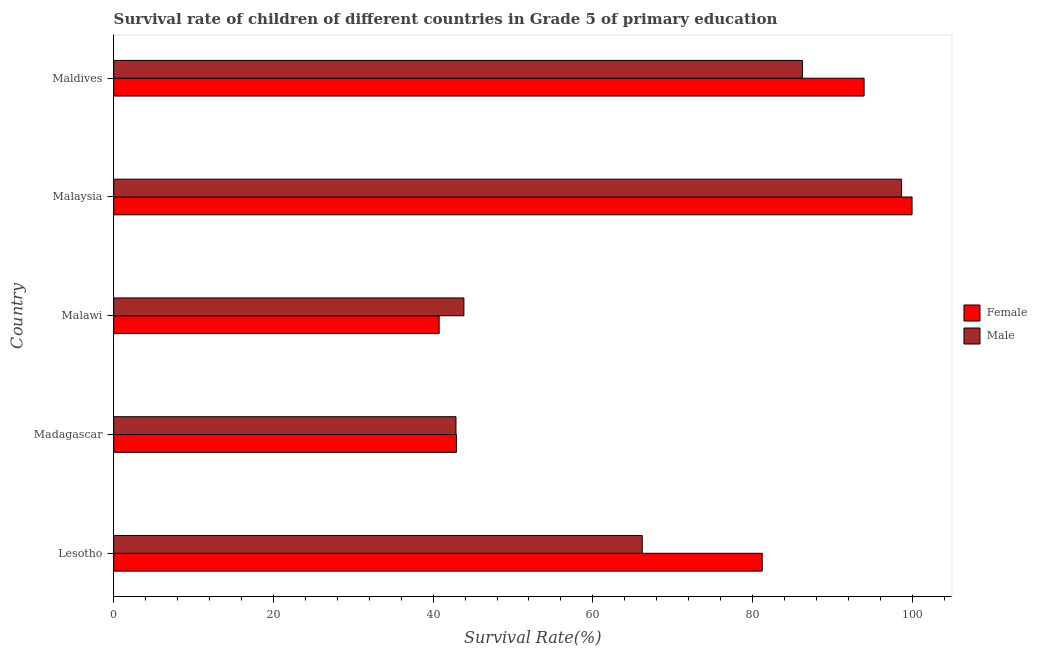How many groups of bars are there?
Give a very brief answer. 5. Are the number of bars on each tick of the Y-axis equal?
Offer a terse response. Yes. How many bars are there on the 4th tick from the bottom?
Make the answer very short. 2. What is the label of the 3rd group of bars from the top?
Offer a very short reply. Malawi. In how many cases, is the number of bars for a given country not equal to the number of legend labels?
Your answer should be very brief. 0. What is the survival rate of male students in primary education in Lesotho?
Provide a succinct answer. 66.18. Across all countries, what is the maximum survival rate of male students in primary education?
Provide a succinct answer. 98.66. Across all countries, what is the minimum survival rate of male students in primary education?
Ensure brevity in your answer.  42.86. In which country was the survival rate of female students in primary education maximum?
Provide a succinct answer. Malaysia. In which country was the survival rate of female students in primary education minimum?
Your response must be concise. Malawi. What is the total survival rate of female students in primary education in the graph?
Offer a terse response. 358.8. What is the difference between the survival rate of male students in primary education in Malaysia and that in Maldives?
Your answer should be very brief. 12.41. What is the difference between the survival rate of female students in primary education in Lesotho and the survival rate of male students in primary education in Malawi?
Make the answer very short. 37.36. What is the average survival rate of male students in primary education per country?
Keep it short and to the point. 67.56. What is the difference between the survival rate of female students in primary education and survival rate of male students in primary education in Lesotho?
Your answer should be very brief. 15.03. What is the ratio of the survival rate of female students in primary education in Malawi to that in Maldives?
Provide a succinct answer. 0.43. What is the difference between the highest and the second highest survival rate of male students in primary education?
Your answer should be very brief. 12.41. What is the difference between the highest and the lowest survival rate of male students in primary education?
Offer a very short reply. 55.8. What does the 2nd bar from the top in Malaysia represents?
Keep it short and to the point. Female. How many bars are there?
Give a very brief answer. 10. Are all the bars in the graph horizontal?
Provide a short and direct response. Yes. How many countries are there in the graph?
Ensure brevity in your answer.  5. Does the graph contain any zero values?
Make the answer very short. No. Where does the legend appear in the graph?
Make the answer very short. Center right. How are the legend labels stacked?
Offer a very short reply. Vertical. What is the title of the graph?
Make the answer very short. Survival rate of children of different countries in Grade 5 of primary education. Does "Nitrous oxide emissions" appear as one of the legend labels in the graph?
Provide a succinct answer. No. What is the label or title of the X-axis?
Give a very brief answer. Survival Rate(%). What is the Survival Rate(%) in Female in Lesotho?
Your answer should be very brief. 81.21. What is the Survival Rate(%) of Male in Lesotho?
Your response must be concise. 66.18. What is the Survival Rate(%) of Female in Madagascar?
Provide a succinct answer. 42.91. What is the Survival Rate(%) of Male in Madagascar?
Make the answer very short. 42.86. What is the Survival Rate(%) in Female in Malawi?
Give a very brief answer. 40.75. What is the Survival Rate(%) in Male in Malawi?
Your answer should be very brief. 43.85. What is the Survival Rate(%) in Female in Malaysia?
Offer a terse response. 99.97. What is the Survival Rate(%) in Male in Malaysia?
Make the answer very short. 98.66. What is the Survival Rate(%) of Female in Maldives?
Make the answer very short. 93.96. What is the Survival Rate(%) of Male in Maldives?
Offer a terse response. 86.24. Across all countries, what is the maximum Survival Rate(%) in Female?
Make the answer very short. 99.97. Across all countries, what is the maximum Survival Rate(%) of Male?
Your answer should be compact. 98.66. Across all countries, what is the minimum Survival Rate(%) in Female?
Provide a succinct answer. 40.75. Across all countries, what is the minimum Survival Rate(%) of Male?
Your answer should be compact. 42.86. What is the total Survival Rate(%) of Female in the graph?
Your answer should be compact. 358.8. What is the total Survival Rate(%) of Male in the graph?
Your answer should be compact. 337.79. What is the difference between the Survival Rate(%) in Female in Lesotho and that in Madagascar?
Your answer should be compact. 38.3. What is the difference between the Survival Rate(%) in Male in Lesotho and that in Madagascar?
Make the answer very short. 23.32. What is the difference between the Survival Rate(%) in Female in Lesotho and that in Malawi?
Provide a succinct answer. 40.46. What is the difference between the Survival Rate(%) in Male in Lesotho and that in Malawi?
Provide a short and direct response. 22.33. What is the difference between the Survival Rate(%) in Female in Lesotho and that in Malaysia?
Offer a very short reply. -18.76. What is the difference between the Survival Rate(%) in Male in Lesotho and that in Malaysia?
Provide a succinct answer. -32.48. What is the difference between the Survival Rate(%) of Female in Lesotho and that in Maldives?
Offer a very short reply. -12.76. What is the difference between the Survival Rate(%) in Male in Lesotho and that in Maldives?
Offer a terse response. -20.06. What is the difference between the Survival Rate(%) in Female in Madagascar and that in Malawi?
Provide a short and direct response. 2.16. What is the difference between the Survival Rate(%) in Male in Madagascar and that in Malawi?
Ensure brevity in your answer.  -0.99. What is the difference between the Survival Rate(%) of Female in Madagascar and that in Malaysia?
Provide a succinct answer. -57.06. What is the difference between the Survival Rate(%) of Male in Madagascar and that in Malaysia?
Offer a terse response. -55.8. What is the difference between the Survival Rate(%) in Female in Madagascar and that in Maldives?
Provide a succinct answer. -51.05. What is the difference between the Survival Rate(%) of Male in Madagascar and that in Maldives?
Make the answer very short. -43.38. What is the difference between the Survival Rate(%) in Female in Malawi and that in Malaysia?
Your answer should be compact. -59.22. What is the difference between the Survival Rate(%) in Male in Malawi and that in Malaysia?
Provide a short and direct response. -54.81. What is the difference between the Survival Rate(%) of Female in Malawi and that in Maldives?
Your answer should be compact. -53.22. What is the difference between the Survival Rate(%) in Male in Malawi and that in Maldives?
Make the answer very short. -42.39. What is the difference between the Survival Rate(%) in Female in Malaysia and that in Maldives?
Make the answer very short. 6.01. What is the difference between the Survival Rate(%) in Male in Malaysia and that in Maldives?
Make the answer very short. 12.41. What is the difference between the Survival Rate(%) in Female in Lesotho and the Survival Rate(%) in Male in Madagascar?
Make the answer very short. 38.35. What is the difference between the Survival Rate(%) in Female in Lesotho and the Survival Rate(%) in Male in Malawi?
Provide a succinct answer. 37.36. What is the difference between the Survival Rate(%) in Female in Lesotho and the Survival Rate(%) in Male in Malaysia?
Your answer should be compact. -17.45. What is the difference between the Survival Rate(%) of Female in Lesotho and the Survival Rate(%) of Male in Maldives?
Offer a terse response. -5.03. What is the difference between the Survival Rate(%) of Female in Madagascar and the Survival Rate(%) of Male in Malawi?
Make the answer very short. -0.94. What is the difference between the Survival Rate(%) in Female in Madagascar and the Survival Rate(%) in Male in Malaysia?
Offer a very short reply. -55.74. What is the difference between the Survival Rate(%) in Female in Madagascar and the Survival Rate(%) in Male in Maldives?
Give a very brief answer. -43.33. What is the difference between the Survival Rate(%) in Female in Malawi and the Survival Rate(%) in Male in Malaysia?
Your answer should be compact. -57.91. What is the difference between the Survival Rate(%) of Female in Malawi and the Survival Rate(%) of Male in Maldives?
Give a very brief answer. -45.49. What is the difference between the Survival Rate(%) of Female in Malaysia and the Survival Rate(%) of Male in Maldives?
Offer a terse response. 13.73. What is the average Survival Rate(%) of Female per country?
Give a very brief answer. 71.76. What is the average Survival Rate(%) in Male per country?
Provide a succinct answer. 67.56. What is the difference between the Survival Rate(%) of Female and Survival Rate(%) of Male in Lesotho?
Your answer should be compact. 15.03. What is the difference between the Survival Rate(%) of Female and Survival Rate(%) of Male in Madagascar?
Offer a very short reply. 0.05. What is the difference between the Survival Rate(%) of Female and Survival Rate(%) of Male in Malawi?
Provide a succinct answer. -3.1. What is the difference between the Survival Rate(%) of Female and Survival Rate(%) of Male in Malaysia?
Keep it short and to the point. 1.31. What is the difference between the Survival Rate(%) in Female and Survival Rate(%) in Male in Maldives?
Offer a very short reply. 7.72. What is the ratio of the Survival Rate(%) of Female in Lesotho to that in Madagascar?
Make the answer very short. 1.89. What is the ratio of the Survival Rate(%) of Male in Lesotho to that in Madagascar?
Make the answer very short. 1.54. What is the ratio of the Survival Rate(%) of Female in Lesotho to that in Malawi?
Offer a very short reply. 1.99. What is the ratio of the Survival Rate(%) in Male in Lesotho to that in Malawi?
Your answer should be very brief. 1.51. What is the ratio of the Survival Rate(%) in Female in Lesotho to that in Malaysia?
Provide a short and direct response. 0.81. What is the ratio of the Survival Rate(%) of Male in Lesotho to that in Malaysia?
Give a very brief answer. 0.67. What is the ratio of the Survival Rate(%) in Female in Lesotho to that in Maldives?
Give a very brief answer. 0.86. What is the ratio of the Survival Rate(%) in Male in Lesotho to that in Maldives?
Make the answer very short. 0.77. What is the ratio of the Survival Rate(%) of Female in Madagascar to that in Malawi?
Ensure brevity in your answer.  1.05. What is the ratio of the Survival Rate(%) of Male in Madagascar to that in Malawi?
Make the answer very short. 0.98. What is the ratio of the Survival Rate(%) in Female in Madagascar to that in Malaysia?
Keep it short and to the point. 0.43. What is the ratio of the Survival Rate(%) in Male in Madagascar to that in Malaysia?
Offer a very short reply. 0.43. What is the ratio of the Survival Rate(%) of Female in Madagascar to that in Maldives?
Your response must be concise. 0.46. What is the ratio of the Survival Rate(%) in Male in Madagascar to that in Maldives?
Offer a terse response. 0.5. What is the ratio of the Survival Rate(%) in Female in Malawi to that in Malaysia?
Ensure brevity in your answer.  0.41. What is the ratio of the Survival Rate(%) in Male in Malawi to that in Malaysia?
Give a very brief answer. 0.44. What is the ratio of the Survival Rate(%) in Female in Malawi to that in Maldives?
Give a very brief answer. 0.43. What is the ratio of the Survival Rate(%) of Male in Malawi to that in Maldives?
Make the answer very short. 0.51. What is the ratio of the Survival Rate(%) in Female in Malaysia to that in Maldives?
Give a very brief answer. 1.06. What is the ratio of the Survival Rate(%) of Male in Malaysia to that in Maldives?
Your answer should be compact. 1.14. What is the difference between the highest and the second highest Survival Rate(%) in Female?
Make the answer very short. 6.01. What is the difference between the highest and the second highest Survival Rate(%) of Male?
Offer a very short reply. 12.41. What is the difference between the highest and the lowest Survival Rate(%) in Female?
Provide a succinct answer. 59.22. What is the difference between the highest and the lowest Survival Rate(%) in Male?
Keep it short and to the point. 55.8. 